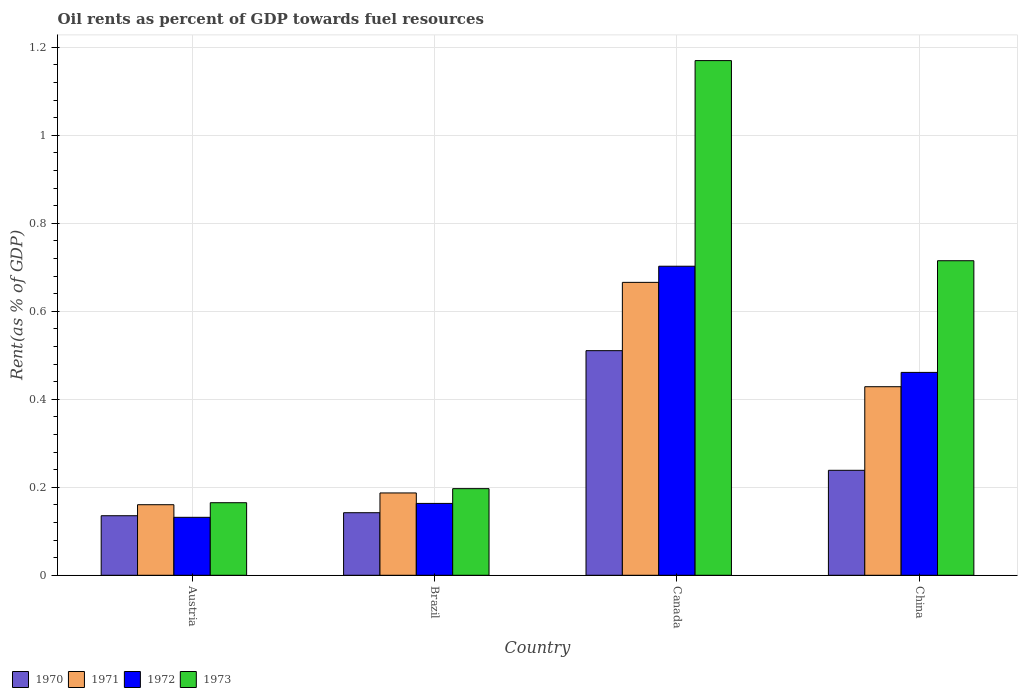How many different coloured bars are there?
Give a very brief answer. 4. Are the number of bars on each tick of the X-axis equal?
Provide a succinct answer. Yes. How many bars are there on the 1st tick from the left?
Ensure brevity in your answer.  4. What is the oil rent in 1971 in China?
Give a very brief answer. 0.43. Across all countries, what is the maximum oil rent in 1973?
Offer a terse response. 1.17. Across all countries, what is the minimum oil rent in 1973?
Keep it short and to the point. 0.16. In which country was the oil rent in 1973 maximum?
Make the answer very short. Canada. What is the total oil rent in 1972 in the graph?
Your answer should be very brief. 1.46. What is the difference between the oil rent in 1973 in Austria and that in Brazil?
Give a very brief answer. -0.03. What is the difference between the oil rent in 1972 in Brazil and the oil rent in 1971 in Austria?
Provide a succinct answer. 0. What is the average oil rent in 1972 per country?
Offer a very short reply. 0.36. What is the difference between the oil rent of/in 1971 and oil rent of/in 1973 in Canada?
Ensure brevity in your answer.  -0.5. In how many countries, is the oil rent in 1972 greater than 0.2 %?
Your response must be concise. 2. What is the ratio of the oil rent in 1973 in Canada to that in China?
Make the answer very short. 1.64. Is the oil rent in 1971 in Austria less than that in Canada?
Give a very brief answer. Yes. Is the difference between the oil rent in 1971 in Austria and Canada greater than the difference between the oil rent in 1973 in Austria and Canada?
Your answer should be very brief. Yes. What is the difference between the highest and the second highest oil rent in 1973?
Your answer should be very brief. -0.45. What is the difference between the highest and the lowest oil rent in 1971?
Your answer should be very brief. 0.51. In how many countries, is the oil rent in 1971 greater than the average oil rent in 1971 taken over all countries?
Offer a terse response. 2. Is it the case that in every country, the sum of the oil rent in 1971 and oil rent in 1973 is greater than the sum of oil rent in 1972 and oil rent in 1970?
Ensure brevity in your answer.  No. What does the 1st bar from the left in Canada represents?
Ensure brevity in your answer.  1970. What does the 3rd bar from the right in Austria represents?
Provide a short and direct response. 1971. Is it the case that in every country, the sum of the oil rent in 1972 and oil rent in 1970 is greater than the oil rent in 1971?
Make the answer very short. Yes. Does the graph contain grids?
Give a very brief answer. Yes. What is the title of the graph?
Offer a very short reply. Oil rents as percent of GDP towards fuel resources. What is the label or title of the Y-axis?
Provide a succinct answer. Rent(as % of GDP). What is the Rent(as % of GDP) in 1970 in Austria?
Provide a succinct answer. 0.14. What is the Rent(as % of GDP) in 1971 in Austria?
Make the answer very short. 0.16. What is the Rent(as % of GDP) of 1972 in Austria?
Your answer should be compact. 0.13. What is the Rent(as % of GDP) in 1973 in Austria?
Ensure brevity in your answer.  0.16. What is the Rent(as % of GDP) in 1970 in Brazil?
Offer a terse response. 0.14. What is the Rent(as % of GDP) of 1971 in Brazil?
Provide a succinct answer. 0.19. What is the Rent(as % of GDP) in 1972 in Brazil?
Offer a terse response. 0.16. What is the Rent(as % of GDP) of 1973 in Brazil?
Your answer should be very brief. 0.2. What is the Rent(as % of GDP) in 1970 in Canada?
Ensure brevity in your answer.  0.51. What is the Rent(as % of GDP) in 1971 in Canada?
Offer a terse response. 0.67. What is the Rent(as % of GDP) in 1972 in Canada?
Offer a terse response. 0.7. What is the Rent(as % of GDP) of 1973 in Canada?
Provide a short and direct response. 1.17. What is the Rent(as % of GDP) of 1970 in China?
Make the answer very short. 0.24. What is the Rent(as % of GDP) of 1971 in China?
Provide a succinct answer. 0.43. What is the Rent(as % of GDP) of 1972 in China?
Offer a terse response. 0.46. What is the Rent(as % of GDP) in 1973 in China?
Provide a succinct answer. 0.71. Across all countries, what is the maximum Rent(as % of GDP) of 1970?
Your answer should be compact. 0.51. Across all countries, what is the maximum Rent(as % of GDP) in 1971?
Provide a succinct answer. 0.67. Across all countries, what is the maximum Rent(as % of GDP) in 1972?
Offer a terse response. 0.7. Across all countries, what is the maximum Rent(as % of GDP) in 1973?
Offer a very short reply. 1.17. Across all countries, what is the minimum Rent(as % of GDP) in 1970?
Ensure brevity in your answer.  0.14. Across all countries, what is the minimum Rent(as % of GDP) in 1971?
Give a very brief answer. 0.16. Across all countries, what is the minimum Rent(as % of GDP) of 1972?
Your response must be concise. 0.13. Across all countries, what is the minimum Rent(as % of GDP) of 1973?
Your answer should be compact. 0.16. What is the total Rent(as % of GDP) in 1970 in the graph?
Offer a very short reply. 1.03. What is the total Rent(as % of GDP) of 1971 in the graph?
Offer a very short reply. 1.44. What is the total Rent(as % of GDP) of 1972 in the graph?
Make the answer very short. 1.46. What is the total Rent(as % of GDP) in 1973 in the graph?
Offer a terse response. 2.25. What is the difference between the Rent(as % of GDP) of 1970 in Austria and that in Brazil?
Provide a succinct answer. -0.01. What is the difference between the Rent(as % of GDP) of 1971 in Austria and that in Brazil?
Provide a short and direct response. -0.03. What is the difference between the Rent(as % of GDP) of 1972 in Austria and that in Brazil?
Your response must be concise. -0.03. What is the difference between the Rent(as % of GDP) of 1973 in Austria and that in Brazil?
Your answer should be compact. -0.03. What is the difference between the Rent(as % of GDP) in 1970 in Austria and that in Canada?
Give a very brief answer. -0.38. What is the difference between the Rent(as % of GDP) in 1971 in Austria and that in Canada?
Ensure brevity in your answer.  -0.51. What is the difference between the Rent(as % of GDP) in 1972 in Austria and that in Canada?
Your response must be concise. -0.57. What is the difference between the Rent(as % of GDP) of 1973 in Austria and that in Canada?
Keep it short and to the point. -1. What is the difference between the Rent(as % of GDP) in 1970 in Austria and that in China?
Your answer should be compact. -0.1. What is the difference between the Rent(as % of GDP) of 1971 in Austria and that in China?
Provide a succinct answer. -0.27. What is the difference between the Rent(as % of GDP) in 1972 in Austria and that in China?
Give a very brief answer. -0.33. What is the difference between the Rent(as % of GDP) in 1973 in Austria and that in China?
Offer a very short reply. -0.55. What is the difference between the Rent(as % of GDP) in 1970 in Brazil and that in Canada?
Your answer should be compact. -0.37. What is the difference between the Rent(as % of GDP) of 1971 in Brazil and that in Canada?
Your answer should be very brief. -0.48. What is the difference between the Rent(as % of GDP) in 1972 in Brazil and that in Canada?
Your response must be concise. -0.54. What is the difference between the Rent(as % of GDP) in 1973 in Brazil and that in Canada?
Provide a succinct answer. -0.97. What is the difference between the Rent(as % of GDP) in 1970 in Brazil and that in China?
Offer a terse response. -0.1. What is the difference between the Rent(as % of GDP) of 1971 in Brazil and that in China?
Keep it short and to the point. -0.24. What is the difference between the Rent(as % of GDP) of 1972 in Brazil and that in China?
Your response must be concise. -0.3. What is the difference between the Rent(as % of GDP) of 1973 in Brazil and that in China?
Offer a terse response. -0.52. What is the difference between the Rent(as % of GDP) of 1970 in Canada and that in China?
Offer a terse response. 0.27. What is the difference between the Rent(as % of GDP) in 1971 in Canada and that in China?
Keep it short and to the point. 0.24. What is the difference between the Rent(as % of GDP) in 1972 in Canada and that in China?
Give a very brief answer. 0.24. What is the difference between the Rent(as % of GDP) in 1973 in Canada and that in China?
Ensure brevity in your answer.  0.45. What is the difference between the Rent(as % of GDP) in 1970 in Austria and the Rent(as % of GDP) in 1971 in Brazil?
Your answer should be very brief. -0.05. What is the difference between the Rent(as % of GDP) in 1970 in Austria and the Rent(as % of GDP) in 1972 in Brazil?
Provide a short and direct response. -0.03. What is the difference between the Rent(as % of GDP) in 1970 in Austria and the Rent(as % of GDP) in 1973 in Brazil?
Give a very brief answer. -0.06. What is the difference between the Rent(as % of GDP) in 1971 in Austria and the Rent(as % of GDP) in 1972 in Brazil?
Your response must be concise. -0. What is the difference between the Rent(as % of GDP) of 1971 in Austria and the Rent(as % of GDP) of 1973 in Brazil?
Your answer should be compact. -0.04. What is the difference between the Rent(as % of GDP) of 1972 in Austria and the Rent(as % of GDP) of 1973 in Brazil?
Keep it short and to the point. -0.07. What is the difference between the Rent(as % of GDP) of 1970 in Austria and the Rent(as % of GDP) of 1971 in Canada?
Keep it short and to the point. -0.53. What is the difference between the Rent(as % of GDP) of 1970 in Austria and the Rent(as % of GDP) of 1972 in Canada?
Keep it short and to the point. -0.57. What is the difference between the Rent(as % of GDP) of 1970 in Austria and the Rent(as % of GDP) of 1973 in Canada?
Provide a succinct answer. -1.03. What is the difference between the Rent(as % of GDP) in 1971 in Austria and the Rent(as % of GDP) in 1972 in Canada?
Offer a very short reply. -0.54. What is the difference between the Rent(as % of GDP) of 1971 in Austria and the Rent(as % of GDP) of 1973 in Canada?
Your answer should be very brief. -1.01. What is the difference between the Rent(as % of GDP) of 1972 in Austria and the Rent(as % of GDP) of 1973 in Canada?
Give a very brief answer. -1.04. What is the difference between the Rent(as % of GDP) in 1970 in Austria and the Rent(as % of GDP) in 1971 in China?
Your answer should be very brief. -0.29. What is the difference between the Rent(as % of GDP) in 1970 in Austria and the Rent(as % of GDP) in 1972 in China?
Ensure brevity in your answer.  -0.33. What is the difference between the Rent(as % of GDP) of 1970 in Austria and the Rent(as % of GDP) of 1973 in China?
Make the answer very short. -0.58. What is the difference between the Rent(as % of GDP) of 1971 in Austria and the Rent(as % of GDP) of 1972 in China?
Offer a very short reply. -0.3. What is the difference between the Rent(as % of GDP) in 1971 in Austria and the Rent(as % of GDP) in 1973 in China?
Provide a succinct answer. -0.55. What is the difference between the Rent(as % of GDP) in 1972 in Austria and the Rent(as % of GDP) in 1973 in China?
Provide a short and direct response. -0.58. What is the difference between the Rent(as % of GDP) in 1970 in Brazil and the Rent(as % of GDP) in 1971 in Canada?
Make the answer very short. -0.52. What is the difference between the Rent(as % of GDP) in 1970 in Brazil and the Rent(as % of GDP) in 1972 in Canada?
Provide a succinct answer. -0.56. What is the difference between the Rent(as % of GDP) in 1970 in Brazil and the Rent(as % of GDP) in 1973 in Canada?
Your answer should be very brief. -1.03. What is the difference between the Rent(as % of GDP) in 1971 in Brazil and the Rent(as % of GDP) in 1972 in Canada?
Keep it short and to the point. -0.52. What is the difference between the Rent(as % of GDP) in 1971 in Brazil and the Rent(as % of GDP) in 1973 in Canada?
Offer a very short reply. -0.98. What is the difference between the Rent(as % of GDP) in 1972 in Brazil and the Rent(as % of GDP) in 1973 in Canada?
Your answer should be very brief. -1.01. What is the difference between the Rent(as % of GDP) of 1970 in Brazil and the Rent(as % of GDP) of 1971 in China?
Your answer should be very brief. -0.29. What is the difference between the Rent(as % of GDP) of 1970 in Brazil and the Rent(as % of GDP) of 1972 in China?
Keep it short and to the point. -0.32. What is the difference between the Rent(as % of GDP) of 1970 in Brazil and the Rent(as % of GDP) of 1973 in China?
Provide a succinct answer. -0.57. What is the difference between the Rent(as % of GDP) in 1971 in Brazil and the Rent(as % of GDP) in 1972 in China?
Ensure brevity in your answer.  -0.27. What is the difference between the Rent(as % of GDP) in 1971 in Brazil and the Rent(as % of GDP) in 1973 in China?
Give a very brief answer. -0.53. What is the difference between the Rent(as % of GDP) of 1972 in Brazil and the Rent(as % of GDP) of 1973 in China?
Ensure brevity in your answer.  -0.55. What is the difference between the Rent(as % of GDP) in 1970 in Canada and the Rent(as % of GDP) in 1971 in China?
Provide a succinct answer. 0.08. What is the difference between the Rent(as % of GDP) in 1970 in Canada and the Rent(as % of GDP) in 1972 in China?
Offer a terse response. 0.05. What is the difference between the Rent(as % of GDP) of 1970 in Canada and the Rent(as % of GDP) of 1973 in China?
Your answer should be compact. -0.2. What is the difference between the Rent(as % of GDP) in 1971 in Canada and the Rent(as % of GDP) in 1972 in China?
Provide a short and direct response. 0.2. What is the difference between the Rent(as % of GDP) in 1971 in Canada and the Rent(as % of GDP) in 1973 in China?
Offer a very short reply. -0.05. What is the difference between the Rent(as % of GDP) in 1972 in Canada and the Rent(as % of GDP) in 1973 in China?
Provide a succinct answer. -0.01. What is the average Rent(as % of GDP) of 1970 per country?
Make the answer very short. 0.26. What is the average Rent(as % of GDP) of 1971 per country?
Provide a short and direct response. 0.36. What is the average Rent(as % of GDP) of 1972 per country?
Offer a very short reply. 0.36. What is the average Rent(as % of GDP) in 1973 per country?
Your answer should be very brief. 0.56. What is the difference between the Rent(as % of GDP) in 1970 and Rent(as % of GDP) in 1971 in Austria?
Give a very brief answer. -0.03. What is the difference between the Rent(as % of GDP) of 1970 and Rent(as % of GDP) of 1972 in Austria?
Your response must be concise. 0. What is the difference between the Rent(as % of GDP) of 1970 and Rent(as % of GDP) of 1973 in Austria?
Make the answer very short. -0.03. What is the difference between the Rent(as % of GDP) in 1971 and Rent(as % of GDP) in 1972 in Austria?
Give a very brief answer. 0.03. What is the difference between the Rent(as % of GDP) in 1971 and Rent(as % of GDP) in 1973 in Austria?
Offer a terse response. -0. What is the difference between the Rent(as % of GDP) of 1972 and Rent(as % of GDP) of 1973 in Austria?
Provide a short and direct response. -0.03. What is the difference between the Rent(as % of GDP) in 1970 and Rent(as % of GDP) in 1971 in Brazil?
Give a very brief answer. -0.04. What is the difference between the Rent(as % of GDP) in 1970 and Rent(as % of GDP) in 1972 in Brazil?
Your answer should be very brief. -0.02. What is the difference between the Rent(as % of GDP) in 1970 and Rent(as % of GDP) in 1973 in Brazil?
Make the answer very short. -0.05. What is the difference between the Rent(as % of GDP) in 1971 and Rent(as % of GDP) in 1972 in Brazil?
Give a very brief answer. 0.02. What is the difference between the Rent(as % of GDP) of 1971 and Rent(as % of GDP) of 1973 in Brazil?
Ensure brevity in your answer.  -0.01. What is the difference between the Rent(as % of GDP) in 1972 and Rent(as % of GDP) in 1973 in Brazil?
Offer a very short reply. -0.03. What is the difference between the Rent(as % of GDP) of 1970 and Rent(as % of GDP) of 1971 in Canada?
Provide a succinct answer. -0.16. What is the difference between the Rent(as % of GDP) of 1970 and Rent(as % of GDP) of 1972 in Canada?
Provide a succinct answer. -0.19. What is the difference between the Rent(as % of GDP) in 1970 and Rent(as % of GDP) in 1973 in Canada?
Ensure brevity in your answer.  -0.66. What is the difference between the Rent(as % of GDP) in 1971 and Rent(as % of GDP) in 1972 in Canada?
Your response must be concise. -0.04. What is the difference between the Rent(as % of GDP) of 1971 and Rent(as % of GDP) of 1973 in Canada?
Keep it short and to the point. -0.5. What is the difference between the Rent(as % of GDP) of 1972 and Rent(as % of GDP) of 1973 in Canada?
Provide a succinct answer. -0.47. What is the difference between the Rent(as % of GDP) of 1970 and Rent(as % of GDP) of 1971 in China?
Provide a succinct answer. -0.19. What is the difference between the Rent(as % of GDP) of 1970 and Rent(as % of GDP) of 1972 in China?
Your response must be concise. -0.22. What is the difference between the Rent(as % of GDP) of 1970 and Rent(as % of GDP) of 1973 in China?
Provide a succinct answer. -0.48. What is the difference between the Rent(as % of GDP) in 1971 and Rent(as % of GDP) in 1972 in China?
Keep it short and to the point. -0.03. What is the difference between the Rent(as % of GDP) of 1971 and Rent(as % of GDP) of 1973 in China?
Your response must be concise. -0.29. What is the difference between the Rent(as % of GDP) of 1972 and Rent(as % of GDP) of 1973 in China?
Keep it short and to the point. -0.25. What is the ratio of the Rent(as % of GDP) of 1970 in Austria to that in Brazil?
Ensure brevity in your answer.  0.95. What is the ratio of the Rent(as % of GDP) in 1971 in Austria to that in Brazil?
Ensure brevity in your answer.  0.86. What is the ratio of the Rent(as % of GDP) of 1972 in Austria to that in Brazil?
Offer a terse response. 0.81. What is the ratio of the Rent(as % of GDP) in 1973 in Austria to that in Brazil?
Keep it short and to the point. 0.84. What is the ratio of the Rent(as % of GDP) of 1970 in Austria to that in Canada?
Keep it short and to the point. 0.27. What is the ratio of the Rent(as % of GDP) in 1971 in Austria to that in Canada?
Ensure brevity in your answer.  0.24. What is the ratio of the Rent(as % of GDP) of 1972 in Austria to that in Canada?
Provide a short and direct response. 0.19. What is the ratio of the Rent(as % of GDP) of 1973 in Austria to that in Canada?
Offer a terse response. 0.14. What is the ratio of the Rent(as % of GDP) in 1970 in Austria to that in China?
Keep it short and to the point. 0.57. What is the ratio of the Rent(as % of GDP) in 1971 in Austria to that in China?
Provide a short and direct response. 0.37. What is the ratio of the Rent(as % of GDP) of 1972 in Austria to that in China?
Provide a succinct answer. 0.29. What is the ratio of the Rent(as % of GDP) of 1973 in Austria to that in China?
Provide a succinct answer. 0.23. What is the ratio of the Rent(as % of GDP) of 1970 in Brazil to that in Canada?
Offer a terse response. 0.28. What is the ratio of the Rent(as % of GDP) in 1971 in Brazil to that in Canada?
Your answer should be very brief. 0.28. What is the ratio of the Rent(as % of GDP) in 1972 in Brazil to that in Canada?
Your answer should be very brief. 0.23. What is the ratio of the Rent(as % of GDP) of 1973 in Brazil to that in Canada?
Your response must be concise. 0.17. What is the ratio of the Rent(as % of GDP) in 1970 in Brazil to that in China?
Provide a short and direct response. 0.6. What is the ratio of the Rent(as % of GDP) of 1971 in Brazil to that in China?
Give a very brief answer. 0.44. What is the ratio of the Rent(as % of GDP) in 1972 in Brazil to that in China?
Ensure brevity in your answer.  0.35. What is the ratio of the Rent(as % of GDP) in 1973 in Brazil to that in China?
Your response must be concise. 0.28. What is the ratio of the Rent(as % of GDP) in 1970 in Canada to that in China?
Your response must be concise. 2.14. What is the ratio of the Rent(as % of GDP) of 1971 in Canada to that in China?
Provide a succinct answer. 1.55. What is the ratio of the Rent(as % of GDP) in 1972 in Canada to that in China?
Your response must be concise. 1.52. What is the ratio of the Rent(as % of GDP) of 1973 in Canada to that in China?
Keep it short and to the point. 1.64. What is the difference between the highest and the second highest Rent(as % of GDP) of 1970?
Offer a terse response. 0.27. What is the difference between the highest and the second highest Rent(as % of GDP) in 1971?
Make the answer very short. 0.24. What is the difference between the highest and the second highest Rent(as % of GDP) of 1972?
Offer a terse response. 0.24. What is the difference between the highest and the second highest Rent(as % of GDP) of 1973?
Your answer should be compact. 0.45. What is the difference between the highest and the lowest Rent(as % of GDP) of 1970?
Provide a short and direct response. 0.38. What is the difference between the highest and the lowest Rent(as % of GDP) of 1971?
Your response must be concise. 0.51. What is the difference between the highest and the lowest Rent(as % of GDP) in 1972?
Your answer should be very brief. 0.57. 